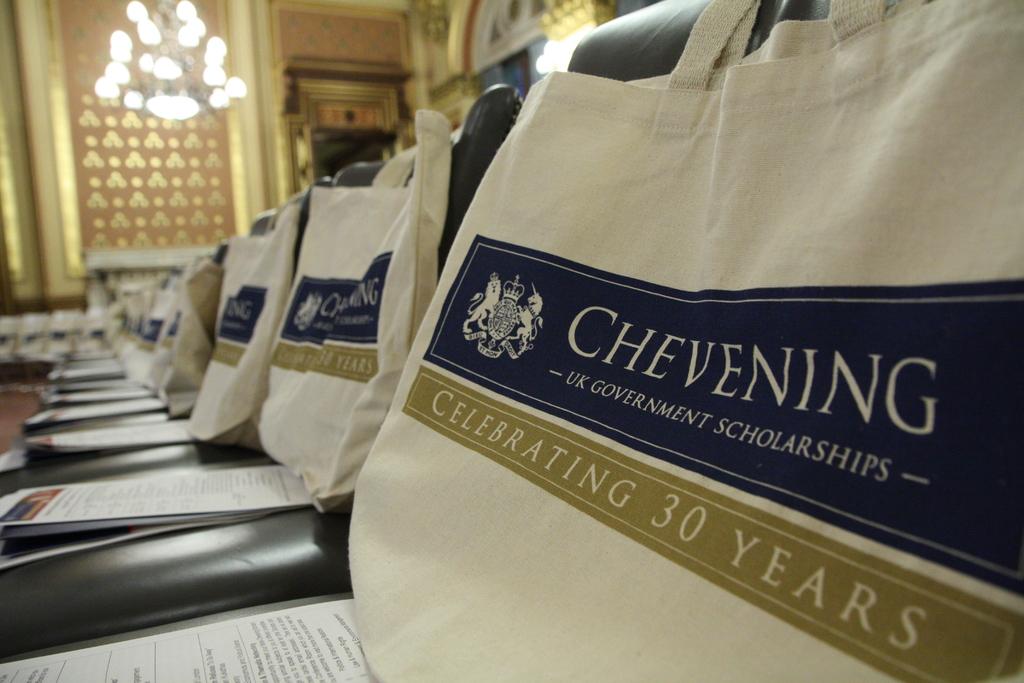How many years is being celebrated?
Ensure brevity in your answer.  30. Which organization is this bag featuring?
Offer a very short reply. Chevening. 